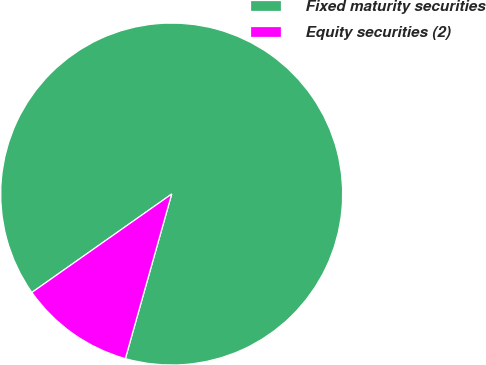<chart> <loc_0><loc_0><loc_500><loc_500><pie_chart><fcel>Fixed maturity securities<fcel>Equity securities (2)<nl><fcel>89.13%<fcel>10.87%<nl></chart> 